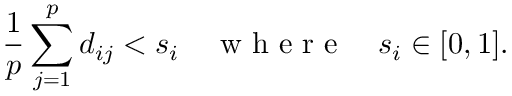<formula> <loc_0><loc_0><loc_500><loc_500>\frac { 1 } { p } \sum _ { j = 1 } ^ { p } d _ { i j } < s _ { i } \quad w h e r e \quad s _ { i } \in [ 0 , 1 ] .</formula> 